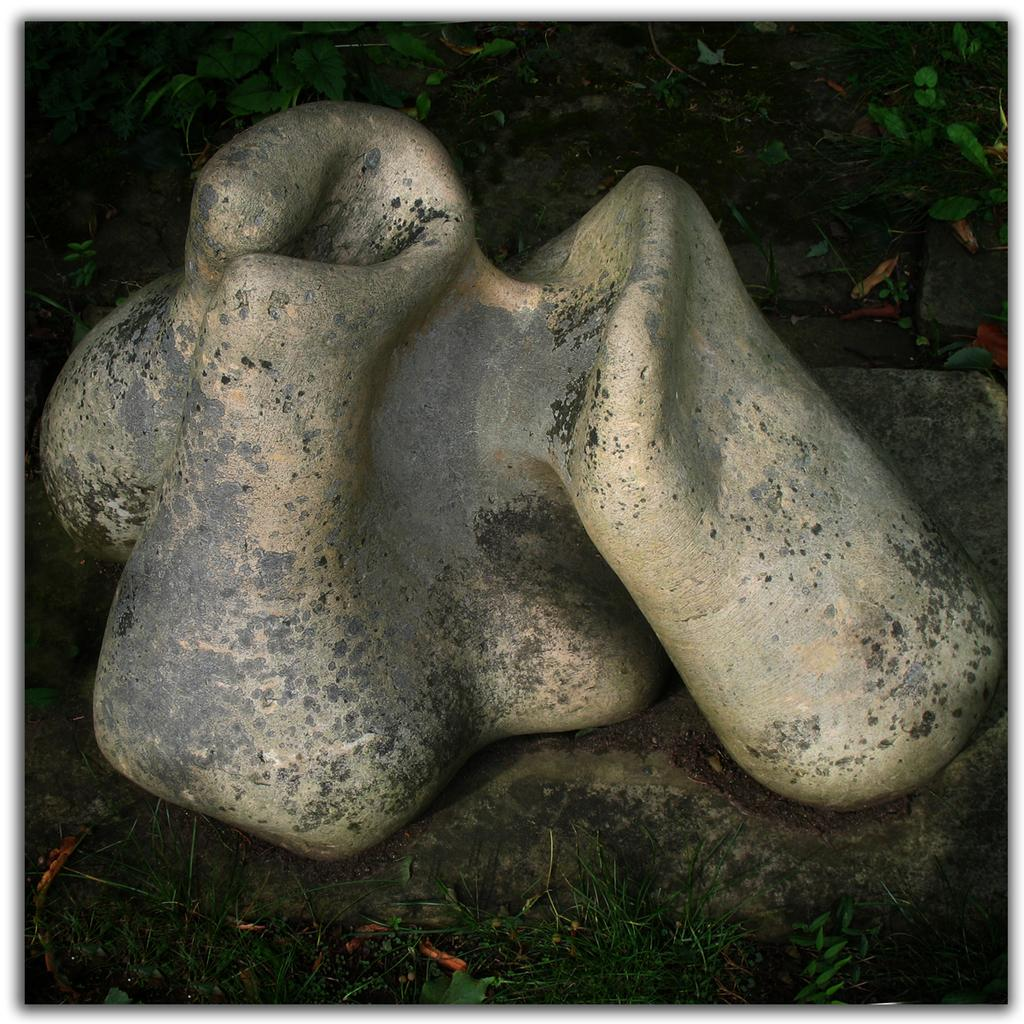What is the main subject in the image? There is an object in the image. What type of living organisms can be seen in the image? Plants can be seen in the image. What type of leather material can be seen in the image? There is no leather material present in the image. What type of hill landscape can be seen in the image? There is no hill landscape present in the image. What type of nut can be seen in the image? There is no nut present in the image. 